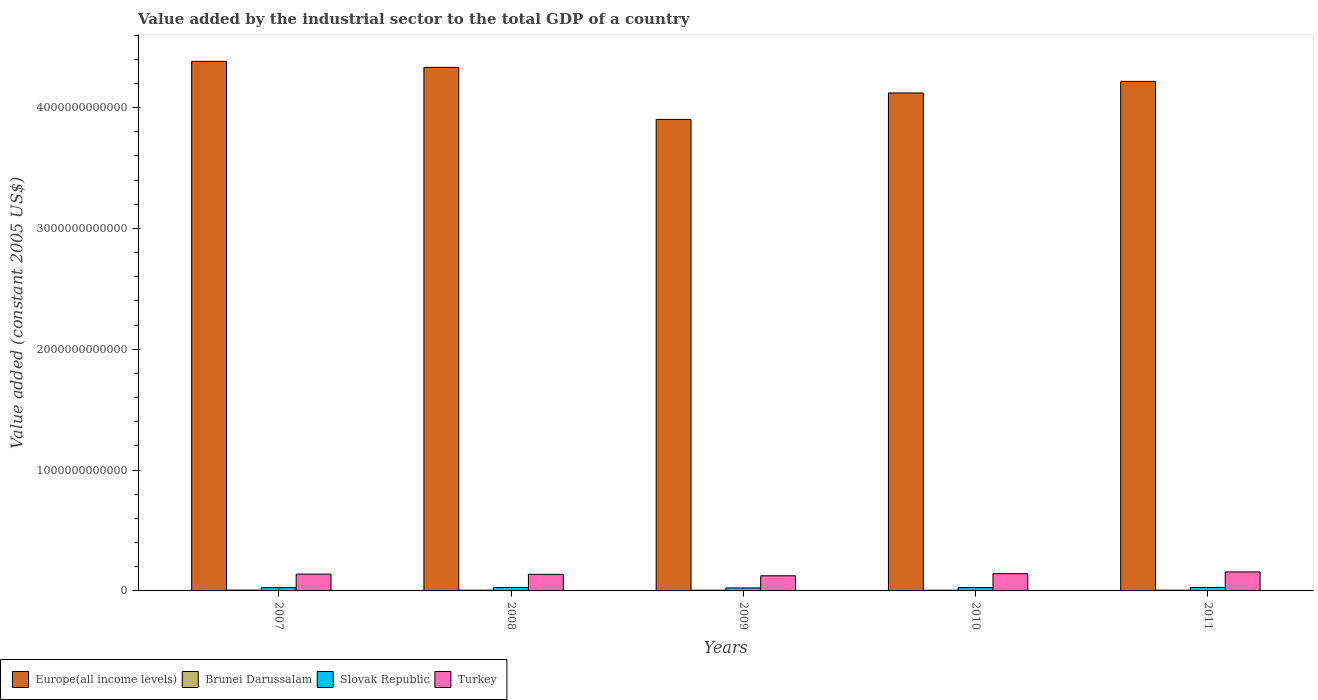How many bars are there on the 2nd tick from the right?
Provide a short and direct response. 4. What is the label of the 1st group of bars from the left?
Your response must be concise. 2007. What is the value added by the industrial sector in Europe(all income levels) in 2007?
Make the answer very short. 4.38e+12. Across all years, what is the maximum value added by the industrial sector in Europe(all income levels)?
Keep it short and to the point. 4.38e+12. Across all years, what is the minimum value added by the industrial sector in Europe(all income levels)?
Your answer should be very brief. 3.90e+12. In which year was the value added by the industrial sector in Brunei Darussalam minimum?
Make the answer very short. 2009. What is the total value added by the industrial sector in Brunei Darussalam in the graph?
Provide a succinct answer. 3.11e+1. What is the difference between the value added by the industrial sector in Slovak Republic in 2007 and that in 2010?
Provide a short and direct response. -1.11e+09. What is the difference between the value added by the industrial sector in Europe(all income levels) in 2011 and the value added by the industrial sector in Brunei Darussalam in 2008?
Your answer should be very brief. 4.21e+12. What is the average value added by the industrial sector in Europe(all income levels) per year?
Give a very brief answer. 4.19e+12. In the year 2009, what is the difference between the value added by the industrial sector in Turkey and value added by the industrial sector in Brunei Darussalam?
Ensure brevity in your answer.  1.19e+11. What is the ratio of the value added by the industrial sector in Turkey in 2007 to that in 2010?
Ensure brevity in your answer.  0.97. Is the value added by the industrial sector in Brunei Darussalam in 2007 less than that in 2009?
Offer a terse response. No. Is the difference between the value added by the industrial sector in Turkey in 2007 and 2008 greater than the difference between the value added by the industrial sector in Brunei Darussalam in 2007 and 2008?
Provide a succinct answer. Yes. What is the difference between the highest and the second highest value added by the industrial sector in Slovak Republic?
Ensure brevity in your answer.  2.55e+08. What is the difference between the highest and the lowest value added by the industrial sector in Slovak Republic?
Your response must be concise. 4.17e+09. In how many years, is the value added by the industrial sector in Brunei Darussalam greater than the average value added by the industrial sector in Brunei Darussalam taken over all years?
Your response must be concise. 3. Is it the case that in every year, the sum of the value added by the industrial sector in Turkey and value added by the industrial sector in Europe(all income levels) is greater than the sum of value added by the industrial sector in Slovak Republic and value added by the industrial sector in Brunei Darussalam?
Keep it short and to the point. Yes. What does the 3rd bar from the left in 2009 represents?
Your answer should be compact. Slovak Republic. What does the 1st bar from the right in 2011 represents?
Your answer should be very brief. Turkey. Is it the case that in every year, the sum of the value added by the industrial sector in Brunei Darussalam and value added by the industrial sector in Europe(all income levels) is greater than the value added by the industrial sector in Turkey?
Make the answer very short. Yes. How many bars are there?
Offer a terse response. 20. Are all the bars in the graph horizontal?
Provide a succinct answer. No. What is the difference between two consecutive major ticks on the Y-axis?
Provide a succinct answer. 1.00e+12. Are the values on the major ticks of Y-axis written in scientific E-notation?
Ensure brevity in your answer.  No. Where does the legend appear in the graph?
Provide a short and direct response. Bottom left. How are the legend labels stacked?
Offer a terse response. Horizontal. What is the title of the graph?
Give a very brief answer. Value added by the industrial sector to the total GDP of a country. Does "Puerto Rico" appear as one of the legend labels in the graph?
Your answer should be compact. No. What is the label or title of the Y-axis?
Make the answer very short. Value added (constant 2005 US$). What is the Value added (constant 2005 US$) of Europe(all income levels) in 2007?
Your answer should be very brief. 4.38e+12. What is the Value added (constant 2005 US$) of Brunei Darussalam in 2007?
Keep it short and to the point. 6.62e+09. What is the Value added (constant 2005 US$) of Slovak Republic in 2007?
Ensure brevity in your answer.  2.66e+1. What is the Value added (constant 2005 US$) in Turkey in 2007?
Offer a very short reply. 1.39e+11. What is the Value added (constant 2005 US$) of Europe(all income levels) in 2008?
Offer a very short reply. 4.33e+12. What is the Value added (constant 2005 US$) of Brunei Darussalam in 2008?
Provide a short and direct response. 6.26e+09. What is the Value added (constant 2005 US$) in Slovak Republic in 2008?
Make the answer very short. 2.87e+1. What is the Value added (constant 2005 US$) of Turkey in 2008?
Offer a very short reply. 1.37e+11. What is the Value added (constant 2005 US$) in Europe(all income levels) in 2009?
Keep it short and to the point. 3.90e+12. What is the Value added (constant 2005 US$) in Brunei Darussalam in 2009?
Provide a short and direct response. 5.95e+09. What is the Value added (constant 2005 US$) in Slovak Republic in 2009?
Provide a short and direct response. 2.48e+1. What is the Value added (constant 2005 US$) in Turkey in 2009?
Give a very brief answer. 1.25e+11. What is the Value added (constant 2005 US$) of Europe(all income levels) in 2010?
Your answer should be very brief. 4.12e+12. What is the Value added (constant 2005 US$) of Brunei Darussalam in 2010?
Ensure brevity in your answer.  6.05e+09. What is the Value added (constant 2005 US$) of Slovak Republic in 2010?
Make the answer very short. 2.77e+1. What is the Value added (constant 2005 US$) of Turkey in 2010?
Make the answer very short. 1.43e+11. What is the Value added (constant 2005 US$) of Europe(all income levels) in 2011?
Offer a very short reply. 4.22e+12. What is the Value added (constant 2005 US$) in Brunei Darussalam in 2011?
Your answer should be very brief. 6.25e+09. What is the Value added (constant 2005 US$) of Slovak Republic in 2011?
Ensure brevity in your answer.  2.89e+1. What is the Value added (constant 2005 US$) of Turkey in 2011?
Make the answer very short. 1.57e+11. Across all years, what is the maximum Value added (constant 2005 US$) in Europe(all income levels)?
Keep it short and to the point. 4.38e+12. Across all years, what is the maximum Value added (constant 2005 US$) in Brunei Darussalam?
Keep it short and to the point. 6.62e+09. Across all years, what is the maximum Value added (constant 2005 US$) of Slovak Republic?
Provide a short and direct response. 2.89e+1. Across all years, what is the maximum Value added (constant 2005 US$) in Turkey?
Provide a succinct answer. 1.57e+11. Across all years, what is the minimum Value added (constant 2005 US$) of Europe(all income levels)?
Ensure brevity in your answer.  3.90e+12. Across all years, what is the minimum Value added (constant 2005 US$) in Brunei Darussalam?
Your response must be concise. 5.95e+09. Across all years, what is the minimum Value added (constant 2005 US$) of Slovak Republic?
Make the answer very short. 2.48e+1. Across all years, what is the minimum Value added (constant 2005 US$) of Turkey?
Your answer should be very brief. 1.25e+11. What is the total Value added (constant 2005 US$) in Europe(all income levels) in the graph?
Make the answer very short. 2.10e+13. What is the total Value added (constant 2005 US$) of Brunei Darussalam in the graph?
Provide a short and direct response. 3.11e+1. What is the total Value added (constant 2005 US$) in Slovak Republic in the graph?
Your answer should be compact. 1.37e+11. What is the total Value added (constant 2005 US$) of Turkey in the graph?
Your answer should be compact. 7.01e+11. What is the difference between the Value added (constant 2005 US$) in Europe(all income levels) in 2007 and that in 2008?
Provide a succinct answer. 4.99e+1. What is the difference between the Value added (constant 2005 US$) of Brunei Darussalam in 2007 and that in 2008?
Offer a very short reply. 3.60e+08. What is the difference between the Value added (constant 2005 US$) in Slovak Republic in 2007 and that in 2008?
Offer a very short reply. -2.08e+09. What is the difference between the Value added (constant 2005 US$) of Turkey in 2007 and that in 2008?
Offer a terse response. 1.81e+09. What is the difference between the Value added (constant 2005 US$) of Europe(all income levels) in 2007 and that in 2009?
Keep it short and to the point. 4.80e+11. What is the difference between the Value added (constant 2005 US$) in Brunei Darussalam in 2007 and that in 2009?
Offer a terse response. 6.75e+08. What is the difference between the Value added (constant 2005 US$) of Slovak Republic in 2007 and that in 2009?
Keep it short and to the point. 1.83e+09. What is the difference between the Value added (constant 2005 US$) of Turkey in 2007 and that in 2009?
Your answer should be compact. 1.36e+1. What is the difference between the Value added (constant 2005 US$) of Europe(all income levels) in 2007 and that in 2010?
Provide a short and direct response. 2.62e+11. What is the difference between the Value added (constant 2005 US$) in Brunei Darussalam in 2007 and that in 2010?
Offer a very short reply. 5.72e+08. What is the difference between the Value added (constant 2005 US$) in Slovak Republic in 2007 and that in 2010?
Offer a terse response. -1.11e+09. What is the difference between the Value added (constant 2005 US$) of Turkey in 2007 and that in 2010?
Provide a succinct answer. -3.78e+09. What is the difference between the Value added (constant 2005 US$) in Europe(all income levels) in 2007 and that in 2011?
Your answer should be very brief. 1.66e+11. What is the difference between the Value added (constant 2005 US$) in Brunei Darussalam in 2007 and that in 2011?
Your answer should be very brief. 3.79e+08. What is the difference between the Value added (constant 2005 US$) in Slovak Republic in 2007 and that in 2011?
Your response must be concise. -2.34e+09. What is the difference between the Value added (constant 2005 US$) of Turkey in 2007 and that in 2011?
Make the answer very short. -1.81e+1. What is the difference between the Value added (constant 2005 US$) of Europe(all income levels) in 2008 and that in 2009?
Keep it short and to the point. 4.30e+11. What is the difference between the Value added (constant 2005 US$) in Brunei Darussalam in 2008 and that in 2009?
Your answer should be compact. 3.14e+08. What is the difference between the Value added (constant 2005 US$) of Slovak Republic in 2008 and that in 2009?
Keep it short and to the point. 3.91e+09. What is the difference between the Value added (constant 2005 US$) of Turkey in 2008 and that in 2009?
Make the answer very short. 1.18e+1. What is the difference between the Value added (constant 2005 US$) in Europe(all income levels) in 2008 and that in 2010?
Give a very brief answer. 2.12e+11. What is the difference between the Value added (constant 2005 US$) of Brunei Darussalam in 2008 and that in 2010?
Provide a succinct answer. 2.12e+08. What is the difference between the Value added (constant 2005 US$) of Slovak Republic in 2008 and that in 2010?
Your response must be concise. 9.77e+08. What is the difference between the Value added (constant 2005 US$) of Turkey in 2008 and that in 2010?
Your response must be concise. -5.60e+09. What is the difference between the Value added (constant 2005 US$) of Europe(all income levels) in 2008 and that in 2011?
Ensure brevity in your answer.  1.16e+11. What is the difference between the Value added (constant 2005 US$) of Brunei Darussalam in 2008 and that in 2011?
Give a very brief answer. 1.89e+07. What is the difference between the Value added (constant 2005 US$) in Slovak Republic in 2008 and that in 2011?
Your response must be concise. -2.55e+08. What is the difference between the Value added (constant 2005 US$) in Turkey in 2008 and that in 2011?
Make the answer very short. -1.99e+1. What is the difference between the Value added (constant 2005 US$) of Europe(all income levels) in 2009 and that in 2010?
Give a very brief answer. -2.19e+11. What is the difference between the Value added (constant 2005 US$) in Brunei Darussalam in 2009 and that in 2010?
Keep it short and to the point. -1.03e+08. What is the difference between the Value added (constant 2005 US$) in Slovak Republic in 2009 and that in 2010?
Keep it short and to the point. -2.94e+09. What is the difference between the Value added (constant 2005 US$) of Turkey in 2009 and that in 2010?
Provide a succinct answer. -1.74e+1. What is the difference between the Value added (constant 2005 US$) in Europe(all income levels) in 2009 and that in 2011?
Ensure brevity in your answer.  -3.15e+11. What is the difference between the Value added (constant 2005 US$) in Brunei Darussalam in 2009 and that in 2011?
Your answer should be compact. -2.95e+08. What is the difference between the Value added (constant 2005 US$) in Slovak Republic in 2009 and that in 2011?
Your answer should be very brief. -4.17e+09. What is the difference between the Value added (constant 2005 US$) of Turkey in 2009 and that in 2011?
Keep it short and to the point. -3.17e+1. What is the difference between the Value added (constant 2005 US$) of Europe(all income levels) in 2010 and that in 2011?
Give a very brief answer. -9.60e+1. What is the difference between the Value added (constant 2005 US$) in Brunei Darussalam in 2010 and that in 2011?
Give a very brief answer. -1.93e+08. What is the difference between the Value added (constant 2005 US$) of Slovak Republic in 2010 and that in 2011?
Provide a succinct answer. -1.23e+09. What is the difference between the Value added (constant 2005 US$) of Turkey in 2010 and that in 2011?
Provide a succinct answer. -1.43e+1. What is the difference between the Value added (constant 2005 US$) of Europe(all income levels) in 2007 and the Value added (constant 2005 US$) of Brunei Darussalam in 2008?
Provide a short and direct response. 4.38e+12. What is the difference between the Value added (constant 2005 US$) of Europe(all income levels) in 2007 and the Value added (constant 2005 US$) of Slovak Republic in 2008?
Provide a succinct answer. 4.35e+12. What is the difference between the Value added (constant 2005 US$) of Europe(all income levels) in 2007 and the Value added (constant 2005 US$) of Turkey in 2008?
Make the answer very short. 4.25e+12. What is the difference between the Value added (constant 2005 US$) in Brunei Darussalam in 2007 and the Value added (constant 2005 US$) in Slovak Republic in 2008?
Ensure brevity in your answer.  -2.20e+1. What is the difference between the Value added (constant 2005 US$) in Brunei Darussalam in 2007 and the Value added (constant 2005 US$) in Turkey in 2008?
Offer a terse response. -1.30e+11. What is the difference between the Value added (constant 2005 US$) of Slovak Republic in 2007 and the Value added (constant 2005 US$) of Turkey in 2008?
Your answer should be compact. -1.11e+11. What is the difference between the Value added (constant 2005 US$) in Europe(all income levels) in 2007 and the Value added (constant 2005 US$) in Brunei Darussalam in 2009?
Give a very brief answer. 4.38e+12. What is the difference between the Value added (constant 2005 US$) of Europe(all income levels) in 2007 and the Value added (constant 2005 US$) of Slovak Republic in 2009?
Your answer should be compact. 4.36e+12. What is the difference between the Value added (constant 2005 US$) in Europe(all income levels) in 2007 and the Value added (constant 2005 US$) in Turkey in 2009?
Your answer should be very brief. 4.26e+12. What is the difference between the Value added (constant 2005 US$) in Brunei Darussalam in 2007 and the Value added (constant 2005 US$) in Slovak Republic in 2009?
Provide a succinct answer. -1.81e+1. What is the difference between the Value added (constant 2005 US$) in Brunei Darussalam in 2007 and the Value added (constant 2005 US$) in Turkey in 2009?
Your answer should be compact. -1.19e+11. What is the difference between the Value added (constant 2005 US$) of Slovak Republic in 2007 and the Value added (constant 2005 US$) of Turkey in 2009?
Provide a short and direct response. -9.87e+1. What is the difference between the Value added (constant 2005 US$) of Europe(all income levels) in 2007 and the Value added (constant 2005 US$) of Brunei Darussalam in 2010?
Offer a terse response. 4.38e+12. What is the difference between the Value added (constant 2005 US$) of Europe(all income levels) in 2007 and the Value added (constant 2005 US$) of Slovak Republic in 2010?
Ensure brevity in your answer.  4.35e+12. What is the difference between the Value added (constant 2005 US$) in Europe(all income levels) in 2007 and the Value added (constant 2005 US$) in Turkey in 2010?
Give a very brief answer. 4.24e+12. What is the difference between the Value added (constant 2005 US$) of Brunei Darussalam in 2007 and the Value added (constant 2005 US$) of Slovak Republic in 2010?
Provide a succinct answer. -2.11e+1. What is the difference between the Value added (constant 2005 US$) of Brunei Darussalam in 2007 and the Value added (constant 2005 US$) of Turkey in 2010?
Give a very brief answer. -1.36e+11. What is the difference between the Value added (constant 2005 US$) in Slovak Republic in 2007 and the Value added (constant 2005 US$) in Turkey in 2010?
Offer a very short reply. -1.16e+11. What is the difference between the Value added (constant 2005 US$) in Europe(all income levels) in 2007 and the Value added (constant 2005 US$) in Brunei Darussalam in 2011?
Provide a short and direct response. 4.38e+12. What is the difference between the Value added (constant 2005 US$) of Europe(all income levels) in 2007 and the Value added (constant 2005 US$) of Slovak Republic in 2011?
Offer a very short reply. 4.35e+12. What is the difference between the Value added (constant 2005 US$) in Europe(all income levels) in 2007 and the Value added (constant 2005 US$) in Turkey in 2011?
Provide a short and direct response. 4.23e+12. What is the difference between the Value added (constant 2005 US$) of Brunei Darussalam in 2007 and the Value added (constant 2005 US$) of Slovak Republic in 2011?
Offer a terse response. -2.23e+1. What is the difference between the Value added (constant 2005 US$) of Brunei Darussalam in 2007 and the Value added (constant 2005 US$) of Turkey in 2011?
Ensure brevity in your answer.  -1.50e+11. What is the difference between the Value added (constant 2005 US$) of Slovak Republic in 2007 and the Value added (constant 2005 US$) of Turkey in 2011?
Make the answer very short. -1.30e+11. What is the difference between the Value added (constant 2005 US$) in Europe(all income levels) in 2008 and the Value added (constant 2005 US$) in Brunei Darussalam in 2009?
Offer a very short reply. 4.33e+12. What is the difference between the Value added (constant 2005 US$) in Europe(all income levels) in 2008 and the Value added (constant 2005 US$) in Slovak Republic in 2009?
Ensure brevity in your answer.  4.31e+12. What is the difference between the Value added (constant 2005 US$) in Europe(all income levels) in 2008 and the Value added (constant 2005 US$) in Turkey in 2009?
Your answer should be very brief. 4.21e+12. What is the difference between the Value added (constant 2005 US$) of Brunei Darussalam in 2008 and the Value added (constant 2005 US$) of Slovak Republic in 2009?
Your answer should be compact. -1.85e+1. What is the difference between the Value added (constant 2005 US$) of Brunei Darussalam in 2008 and the Value added (constant 2005 US$) of Turkey in 2009?
Keep it short and to the point. -1.19e+11. What is the difference between the Value added (constant 2005 US$) of Slovak Republic in 2008 and the Value added (constant 2005 US$) of Turkey in 2009?
Keep it short and to the point. -9.66e+1. What is the difference between the Value added (constant 2005 US$) of Europe(all income levels) in 2008 and the Value added (constant 2005 US$) of Brunei Darussalam in 2010?
Ensure brevity in your answer.  4.33e+12. What is the difference between the Value added (constant 2005 US$) of Europe(all income levels) in 2008 and the Value added (constant 2005 US$) of Slovak Republic in 2010?
Keep it short and to the point. 4.31e+12. What is the difference between the Value added (constant 2005 US$) of Europe(all income levels) in 2008 and the Value added (constant 2005 US$) of Turkey in 2010?
Your response must be concise. 4.19e+12. What is the difference between the Value added (constant 2005 US$) in Brunei Darussalam in 2008 and the Value added (constant 2005 US$) in Slovak Republic in 2010?
Your response must be concise. -2.14e+1. What is the difference between the Value added (constant 2005 US$) in Brunei Darussalam in 2008 and the Value added (constant 2005 US$) in Turkey in 2010?
Offer a very short reply. -1.36e+11. What is the difference between the Value added (constant 2005 US$) of Slovak Republic in 2008 and the Value added (constant 2005 US$) of Turkey in 2010?
Your answer should be very brief. -1.14e+11. What is the difference between the Value added (constant 2005 US$) of Europe(all income levels) in 2008 and the Value added (constant 2005 US$) of Brunei Darussalam in 2011?
Provide a succinct answer. 4.33e+12. What is the difference between the Value added (constant 2005 US$) in Europe(all income levels) in 2008 and the Value added (constant 2005 US$) in Slovak Republic in 2011?
Ensure brevity in your answer.  4.30e+12. What is the difference between the Value added (constant 2005 US$) of Europe(all income levels) in 2008 and the Value added (constant 2005 US$) of Turkey in 2011?
Make the answer very short. 4.18e+12. What is the difference between the Value added (constant 2005 US$) of Brunei Darussalam in 2008 and the Value added (constant 2005 US$) of Slovak Republic in 2011?
Ensure brevity in your answer.  -2.27e+1. What is the difference between the Value added (constant 2005 US$) in Brunei Darussalam in 2008 and the Value added (constant 2005 US$) in Turkey in 2011?
Your response must be concise. -1.51e+11. What is the difference between the Value added (constant 2005 US$) in Slovak Republic in 2008 and the Value added (constant 2005 US$) in Turkey in 2011?
Offer a very short reply. -1.28e+11. What is the difference between the Value added (constant 2005 US$) in Europe(all income levels) in 2009 and the Value added (constant 2005 US$) in Brunei Darussalam in 2010?
Give a very brief answer. 3.90e+12. What is the difference between the Value added (constant 2005 US$) in Europe(all income levels) in 2009 and the Value added (constant 2005 US$) in Slovak Republic in 2010?
Make the answer very short. 3.87e+12. What is the difference between the Value added (constant 2005 US$) in Europe(all income levels) in 2009 and the Value added (constant 2005 US$) in Turkey in 2010?
Offer a very short reply. 3.76e+12. What is the difference between the Value added (constant 2005 US$) in Brunei Darussalam in 2009 and the Value added (constant 2005 US$) in Slovak Republic in 2010?
Give a very brief answer. -2.17e+1. What is the difference between the Value added (constant 2005 US$) in Brunei Darussalam in 2009 and the Value added (constant 2005 US$) in Turkey in 2010?
Ensure brevity in your answer.  -1.37e+11. What is the difference between the Value added (constant 2005 US$) of Slovak Republic in 2009 and the Value added (constant 2005 US$) of Turkey in 2010?
Your response must be concise. -1.18e+11. What is the difference between the Value added (constant 2005 US$) of Europe(all income levels) in 2009 and the Value added (constant 2005 US$) of Brunei Darussalam in 2011?
Keep it short and to the point. 3.90e+12. What is the difference between the Value added (constant 2005 US$) in Europe(all income levels) in 2009 and the Value added (constant 2005 US$) in Slovak Republic in 2011?
Offer a very short reply. 3.87e+12. What is the difference between the Value added (constant 2005 US$) in Europe(all income levels) in 2009 and the Value added (constant 2005 US$) in Turkey in 2011?
Your response must be concise. 3.75e+12. What is the difference between the Value added (constant 2005 US$) in Brunei Darussalam in 2009 and the Value added (constant 2005 US$) in Slovak Republic in 2011?
Your answer should be very brief. -2.30e+1. What is the difference between the Value added (constant 2005 US$) of Brunei Darussalam in 2009 and the Value added (constant 2005 US$) of Turkey in 2011?
Provide a succinct answer. -1.51e+11. What is the difference between the Value added (constant 2005 US$) in Slovak Republic in 2009 and the Value added (constant 2005 US$) in Turkey in 2011?
Keep it short and to the point. -1.32e+11. What is the difference between the Value added (constant 2005 US$) of Europe(all income levels) in 2010 and the Value added (constant 2005 US$) of Brunei Darussalam in 2011?
Your answer should be very brief. 4.11e+12. What is the difference between the Value added (constant 2005 US$) in Europe(all income levels) in 2010 and the Value added (constant 2005 US$) in Slovak Republic in 2011?
Give a very brief answer. 4.09e+12. What is the difference between the Value added (constant 2005 US$) of Europe(all income levels) in 2010 and the Value added (constant 2005 US$) of Turkey in 2011?
Ensure brevity in your answer.  3.96e+12. What is the difference between the Value added (constant 2005 US$) of Brunei Darussalam in 2010 and the Value added (constant 2005 US$) of Slovak Republic in 2011?
Ensure brevity in your answer.  -2.29e+1. What is the difference between the Value added (constant 2005 US$) in Brunei Darussalam in 2010 and the Value added (constant 2005 US$) in Turkey in 2011?
Keep it short and to the point. -1.51e+11. What is the difference between the Value added (constant 2005 US$) in Slovak Republic in 2010 and the Value added (constant 2005 US$) in Turkey in 2011?
Offer a terse response. -1.29e+11. What is the average Value added (constant 2005 US$) in Europe(all income levels) per year?
Make the answer very short. 4.19e+12. What is the average Value added (constant 2005 US$) in Brunei Darussalam per year?
Keep it short and to the point. 6.23e+09. What is the average Value added (constant 2005 US$) in Slovak Republic per year?
Offer a very short reply. 2.73e+1. What is the average Value added (constant 2005 US$) in Turkey per year?
Your answer should be compact. 1.40e+11. In the year 2007, what is the difference between the Value added (constant 2005 US$) of Europe(all income levels) and Value added (constant 2005 US$) of Brunei Darussalam?
Offer a very short reply. 4.38e+12. In the year 2007, what is the difference between the Value added (constant 2005 US$) in Europe(all income levels) and Value added (constant 2005 US$) in Slovak Republic?
Offer a terse response. 4.36e+12. In the year 2007, what is the difference between the Value added (constant 2005 US$) in Europe(all income levels) and Value added (constant 2005 US$) in Turkey?
Offer a terse response. 4.24e+12. In the year 2007, what is the difference between the Value added (constant 2005 US$) in Brunei Darussalam and Value added (constant 2005 US$) in Slovak Republic?
Your answer should be compact. -2.00e+1. In the year 2007, what is the difference between the Value added (constant 2005 US$) of Brunei Darussalam and Value added (constant 2005 US$) of Turkey?
Offer a very short reply. -1.32e+11. In the year 2007, what is the difference between the Value added (constant 2005 US$) in Slovak Republic and Value added (constant 2005 US$) in Turkey?
Provide a short and direct response. -1.12e+11. In the year 2008, what is the difference between the Value added (constant 2005 US$) of Europe(all income levels) and Value added (constant 2005 US$) of Brunei Darussalam?
Offer a very short reply. 4.33e+12. In the year 2008, what is the difference between the Value added (constant 2005 US$) of Europe(all income levels) and Value added (constant 2005 US$) of Slovak Republic?
Give a very brief answer. 4.30e+12. In the year 2008, what is the difference between the Value added (constant 2005 US$) in Europe(all income levels) and Value added (constant 2005 US$) in Turkey?
Your response must be concise. 4.20e+12. In the year 2008, what is the difference between the Value added (constant 2005 US$) of Brunei Darussalam and Value added (constant 2005 US$) of Slovak Republic?
Keep it short and to the point. -2.24e+1. In the year 2008, what is the difference between the Value added (constant 2005 US$) of Brunei Darussalam and Value added (constant 2005 US$) of Turkey?
Your answer should be very brief. -1.31e+11. In the year 2008, what is the difference between the Value added (constant 2005 US$) of Slovak Republic and Value added (constant 2005 US$) of Turkey?
Provide a succinct answer. -1.08e+11. In the year 2009, what is the difference between the Value added (constant 2005 US$) in Europe(all income levels) and Value added (constant 2005 US$) in Brunei Darussalam?
Offer a very short reply. 3.90e+12. In the year 2009, what is the difference between the Value added (constant 2005 US$) in Europe(all income levels) and Value added (constant 2005 US$) in Slovak Republic?
Provide a succinct answer. 3.88e+12. In the year 2009, what is the difference between the Value added (constant 2005 US$) of Europe(all income levels) and Value added (constant 2005 US$) of Turkey?
Your answer should be very brief. 3.78e+12. In the year 2009, what is the difference between the Value added (constant 2005 US$) in Brunei Darussalam and Value added (constant 2005 US$) in Slovak Republic?
Offer a terse response. -1.88e+1. In the year 2009, what is the difference between the Value added (constant 2005 US$) in Brunei Darussalam and Value added (constant 2005 US$) in Turkey?
Keep it short and to the point. -1.19e+11. In the year 2009, what is the difference between the Value added (constant 2005 US$) of Slovak Republic and Value added (constant 2005 US$) of Turkey?
Ensure brevity in your answer.  -1.01e+11. In the year 2010, what is the difference between the Value added (constant 2005 US$) of Europe(all income levels) and Value added (constant 2005 US$) of Brunei Darussalam?
Keep it short and to the point. 4.11e+12. In the year 2010, what is the difference between the Value added (constant 2005 US$) of Europe(all income levels) and Value added (constant 2005 US$) of Slovak Republic?
Keep it short and to the point. 4.09e+12. In the year 2010, what is the difference between the Value added (constant 2005 US$) in Europe(all income levels) and Value added (constant 2005 US$) in Turkey?
Keep it short and to the point. 3.98e+12. In the year 2010, what is the difference between the Value added (constant 2005 US$) in Brunei Darussalam and Value added (constant 2005 US$) in Slovak Republic?
Offer a terse response. -2.16e+1. In the year 2010, what is the difference between the Value added (constant 2005 US$) in Brunei Darussalam and Value added (constant 2005 US$) in Turkey?
Make the answer very short. -1.37e+11. In the year 2010, what is the difference between the Value added (constant 2005 US$) of Slovak Republic and Value added (constant 2005 US$) of Turkey?
Make the answer very short. -1.15e+11. In the year 2011, what is the difference between the Value added (constant 2005 US$) in Europe(all income levels) and Value added (constant 2005 US$) in Brunei Darussalam?
Keep it short and to the point. 4.21e+12. In the year 2011, what is the difference between the Value added (constant 2005 US$) of Europe(all income levels) and Value added (constant 2005 US$) of Slovak Republic?
Offer a very short reply. 4.19e+12. In the year 2011, what is the difference between the Value added (constant 2005 US$) of Europe(all income levels) and Value added (constant 2005 US$) of Turkey?
Give a very brief answer. 4.06e+12. In the year 2011, what is the difference between the Value added (constant 2005 US$) of Brunei Darussalam and Value added (constant 2005 US$) of Slovak Republic?
Offer a very short reply. -2.27e+1. In the year 2011, what is the difference between the Value added (constant 2005 US$) of Brunei Darussalam and Value added (constant 2005 US$) of Turkey?
Keep it short and to the point. -1.51e+11. In the year 2011, what is the difference between the Value added (constant 2005 US$) in Slovak Republic and Value added (constant 2005 US$) in Turkey?
Your answer should be compact. -1.28e+11. What is the ratio of the Value added (constant 2005 US$) in Europe(all income levels) in 2007 to that in 2008?
Your response must be concise. 1.01. What is the ratio of the Value added (constant 2005 US$) in Brunei Darussalam in 2007 to that in 2008?
Offer a very short reply. 1.06. What is the ratio of the Value added (constant 2005 US$) in Slovak Republic in 2007 to that in 2008?
Your answer should be compact. 0.93. What is the ratio of the Value added (constant 2005 US$) of Turkey in 2007 to that in 2008?
Offer a very short reply. 1.01. What is the ratio of the Value added (constant 2005 US$) of Europe(all income levels) in 2007 to that in 2009?
Give a very brief answer. 1.12. What is the ratio of the Value added (constant 2005 US$) of Brunei Darussalam in 2007 to that in 2009?
Your answer should be compact. 1.11. What is the ratio of the Value added (constant 2005 US$) in Slovak Republic in 2007 to that in 2009?
Your response must be concise. 1.07. What is the ratio of the Value added (constant 2005 US$) of Turkey in 2007 to that in 2009?
Your answer should be very brief. 1.11. What is the ratio of the Value added (constant 2005 US$) of Europe(all income levels) in 2007 to that in 2010?
Give a very brief answer. 1.06. What is the ratio of the Value added (constant 2005 US$) in Brunei Darussalam in 2007 to that in 2010?
Offer a very short reply. 1.09. What is the ratio of the Value added (constant 2005 US$) in Slovak Republic in 2007 to that in 2010?
Keep it short and to the point. 0.96. What is the ratio of the Value added (constant 2005 US$) of Turkey in 2007 to that in 2010?
Your response must be concise. 0.97. What is the ratio of the Value added (constant 2005 US$) in Europe(all income levels) in 2007 to that in 2011?
Your response must be concise. 1.04. What is the ratio of the Value added (constant 2005 US$) in Brunei Darussalam in 2007 to that in 2011?
Ensure brevity in your answer.  1.06. What is the ratio of the Value added (constant 2005 US$) of Slovak Republic in 2007 to that in 2011?
Your answer should be compact. 0.92. What is the ratio of the Value added (constant 2005 US$) in Turkey in 2007 to that in 2011?
Offer a terse response. 0.88. What is the ratio of the Value added (constant 2005 US$) of Europe(all income levels) in 2008 to that in 2009?
Your response must be concise. 1.11. What is the ratio of the Value added (constant 2005 US$) of Brunei Darussalam in 2008 to that in 2009?
Ensure brevity in your answer.  1.05. What is the ratio of the Value added (constant 2005 US$) in Slovak Republic in 2008 to that in 2009?
Your response must be concise. 1.16. What is the ratio of the Value added (constant 2005 US$) in Turkey in 2008 to that in 2009?
Provide a short and direct response. 1.09. What is the ratio of the Value added (constant 2005 US$) in Europe(all income levels) in 2008 to that in 2010?
Offer a terse response. 1.05. What is the ratio of the Value added (constant 2005 US$) of Brunei Darussalam in 2008 to that in 2010?
Keep it short and to the point. 1.03. What is the ratio of the Value added (constant 2005 US$) in Slovak Republic in 2008 to that in 2010?
Your response must be concise. 1.04. What is the ratio of the Value added (constant 2005 US$) of Turkey in 2008 to that in 2010?
Your answer should be compact. 0.96. What is the ratio of the Value added (constant 2005 US$) in Europe(all income levels) in 2008 to that in 2011?
Keep it short and to the point. 1.03. What is the ratio of the Value added (constant 2005 US$) of Brunei Darussalam in 2008 to that in 2011?
Keep it short and to the point. 1. What is the ratio of the Value added (constant 2005 US$) of Slovak Republic in 2008 to that in 2011?
Provide a succinct answer. 0.99. What is the ratio of the Value added (constant 2005 US$) in Turkey in 2008 to that in 2011?
Offer a very short reply. 0.87. What is the ratio of the Value added (constant 2005 US$) in Europe(all income levels) in 2009 to that in 2010?
Provide a short and direct response. 0.95. What is the ratio of the Value added (constant 2005 US$) of Brunei Darussalam in 2009 to that in 2010?
Make the answer very short. 0.98. What is the ratio of the Value added (constant 2005 US$) of Slovak Republic in 2009 to that in 2010?
Your answer should be compact. 0.89. What is the ratio of the Value added (constant 2005 US$) of Turkey in 2009 to that in 2010?
Your answer should be compact. 0.88. What is the ratio of the Value added (constant 2005 US$) in Europe(all income levels) in 2009 to that in 2011?
Provide a short and direct response. 0.93. What is the ratio of the Value added (constant 2005 US$) in Brunei Darussalam in 2009 to that in 2011?
Keep it short and to the point. 0.95. What is the ratio of the Value added (constant 2005 US$) in Slovak Republic in 2009 to that in 2011?
Provide a short and direct response. 0.86. What is the ratio of the Value added (constant 2005 US$) of Turkey in 2009 to that in 2011?
Provide a short and direct response. 0.8. What is the ratio of the Value added (constant 2005 US$) of Europe(all income levels) in 2010 to that in 2011?
Your response must be concise. 0.98. What is the ratio of the Value added (constant 2005 US$) of Brunei Darussalam in 2010 to that in 2011?
Your answer should be very brief. 0.97. What is the ratio of the Value added (constant 2005 US$) of Slovak Republic in 2010 to that in 2011?
Your answer should be very brief. 0.96. What is the ratio of the Value added (constant 2005 US$) in Turkey in 2010 to that in 2011?
Your answer should be compact. 0.91. What is the difference between the highest and the second highest Value added (constant 2005 US$) in Europe(all income levels)?
Offer a very short reply. 4.99e+1. What is the difference between the highest and the second highest Value added (constant 2005 US$) in Brunei Darussalam?
Your answer should be very brief. 3.60e+08. What is the difference between the highest and the second highest Value added (constant 2005 US$) of Slovak Republic?
Give a very brief answer. 2.55e+08. What is the difference between the highest and the second highest Value added (constant 2005 US$) of Turkey?
Provide a succinct answer. 1.43e+1. What is the difference between the highest and the lowest Value added (constant 2005 US$) of Europe(all income levels)?
Your answer should be very brief. 4.80e+11. What is the difference between the highest and the lowest Value added (constant 2005 US$) of Brunei Darussalam?
Your answer should be compact. 6.75e+08. What is the difference between the highest and the lowest Value added (constant 2005 US$) in Slovak Republic?
Your answer should be compact. 4.17e+09. What is the difference between the highest and the lowest Value added (constant 2005 US$) in Turkey?
Make the answer very short. 3.17e+1. 